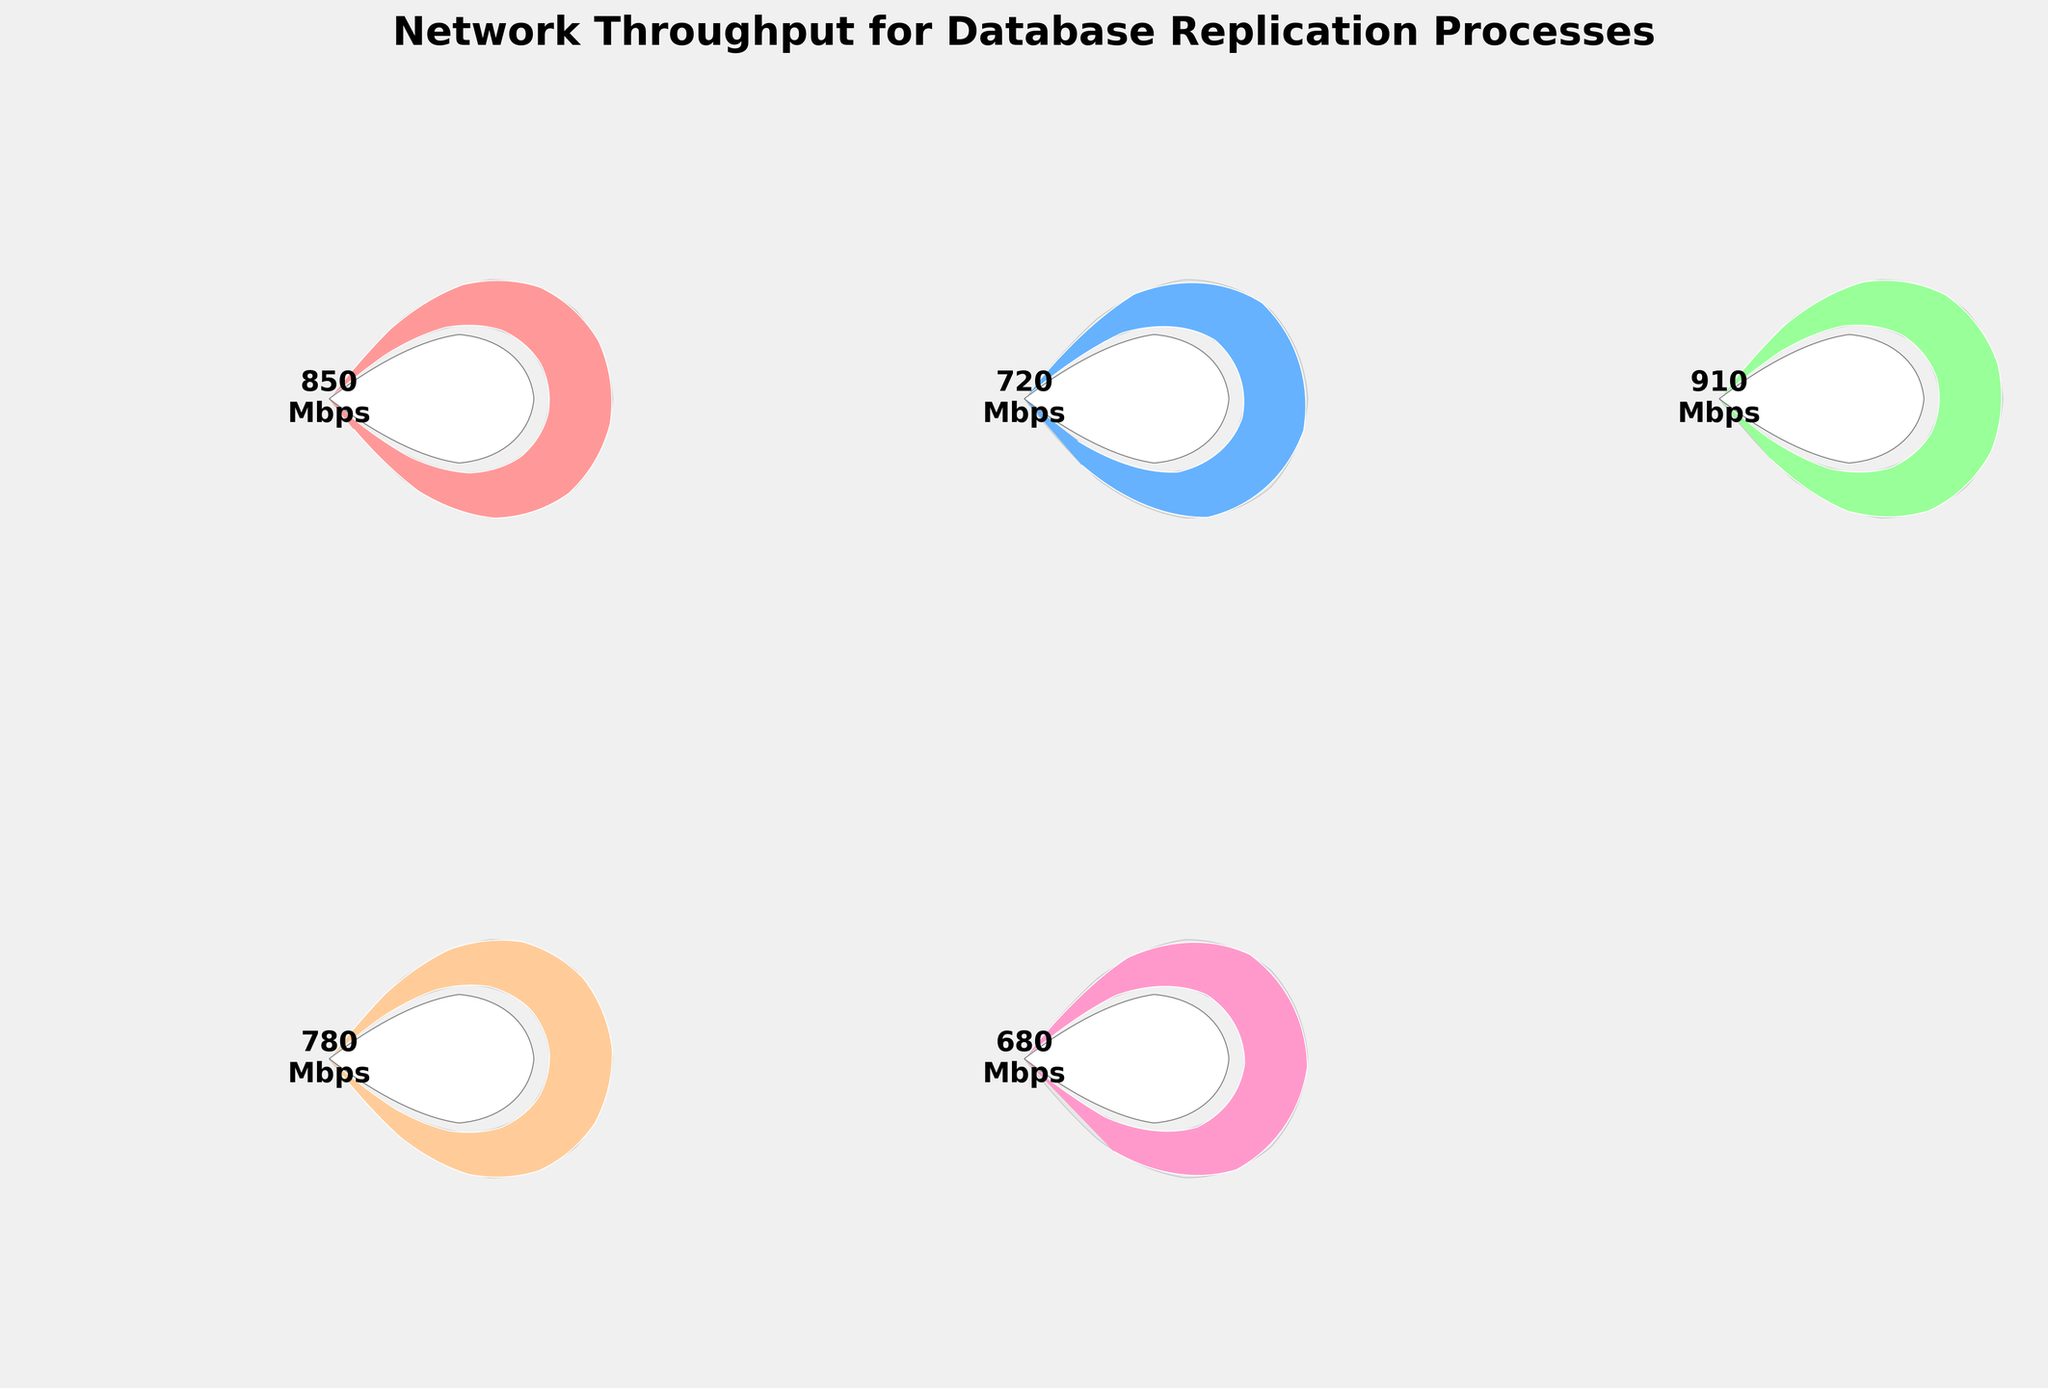What's the title of the figure? The title of the figure is displayed at the top of the figure. It reads "Network Throughput for Database Replication Processes."
Answer: Network Throughput for Database Replication Processes How many subplots are there in the figure? The figure has a 2x3 grid, but the last subplot is unused and removed. Therefore, there are 5 subplots in total.
Answer: 5 Which network has the highest throughput? From the gauge charts, "SQL Server AlwaysOn" has the highest throughput, showing a value of 910 Mbps.
Answer: SQL Server AlwaysOn What is the throughput of MySQL Cluster Replication? By looking at the respective gauge chart for MySQL Cluster Replication, it shows a value of 720 Mbps.
Answer: 720 Mbps What color is the gauge chart for PostgreSQL Streaming Replication? The color of the wedge corresponding to PostgreSQL Streaming Replication is light green, indicating its throughput.
Answer: green Which network has the lowest throughput? By comparing all gauge charts, "MariaDB Galera Cluster" has the lowest throughput at 680 Mbps.
Answer: MariaDB Galera Cluster Is there any network with a throughput above 900 Mbps? If yes, which one? Yes, the gauge chart for "SQL Server AlwaysOn" shows a throughput of 910 Mbps, which is above 900 Mbps.
Answer: Yes, SQL Server AlwaysOn What is the difference in throughput between the highest and lowest performing networks? The highest performing network is SQL Server AlwaysOn (910 Mbps) and the lowest is MariaDB Galera Cluster (680 Mbps). The difference is calculated as 910 - 680 = 230 Mbps.
Answer: 230 Mbps On average, how close are the throughput values to the maximum throughput of 1000 Mbps? The average throughput can be calculated by summing the throughputs (850 + 720 + 910 + 780 + 680) and dividing by 5. That is 3940 / 5 = 788 Mbps. The average proximity to 1000 Mbps is 1000 - 788 = 212 Mbps.
Answer: 212 Mbps Which networks have a throughput below 800 Mbps? From the gauge charts, "MySQL Cluster Replication" (720 Mbps), "PostgreSQL Streaming Replication" (780 Mbps), and "MariaDB Galera Cluster" (680 Mbps) have throughputs below 800 Mbps.
Answer: MySQL Cluster Replication, PostgreSQL Streaming Replication, MariaDB Galera Cluster 